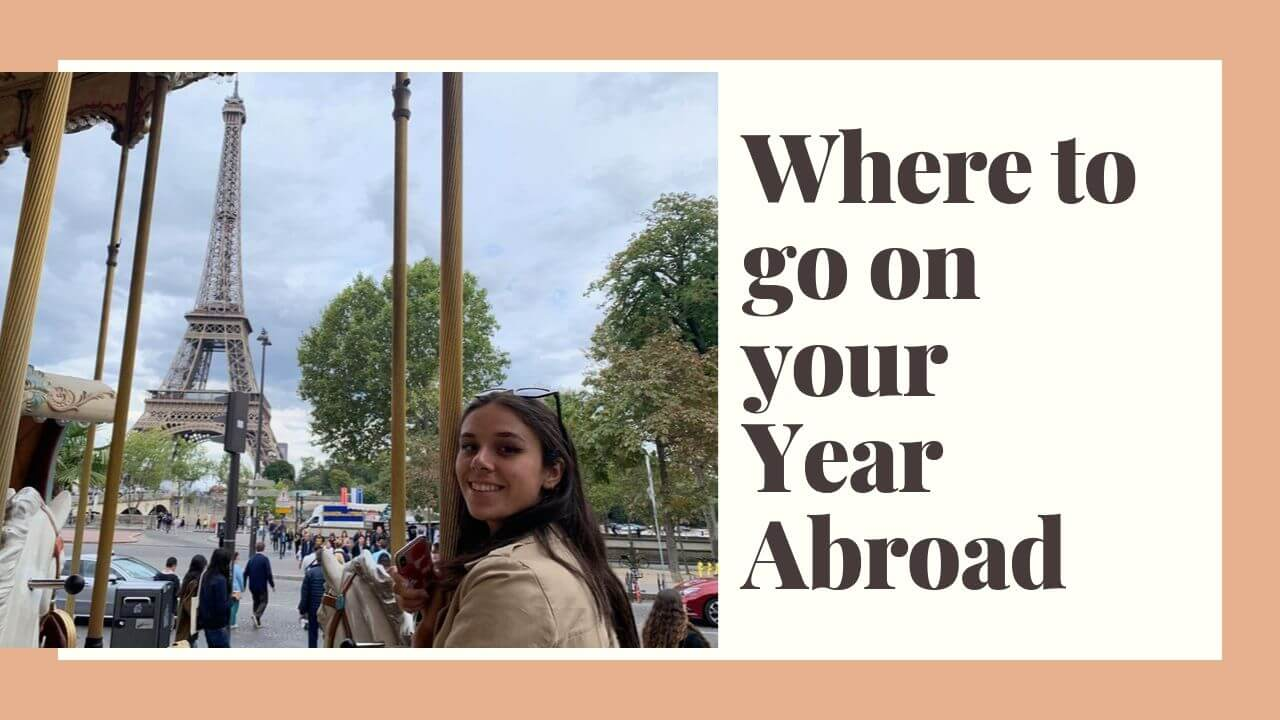Considering the Eiffel Tower is a symbol of Paris, what other Parisian spots might be featured in this graphic series? Other Parisian spots that could be featured in this graphic series might include: the Louvre Museum with its famous glass pyramid entrance, the charming neighborhoods of Montmartre with the Basilica of Sacré-Cœur, Notre-Dame Cathedral, the chic cafes and boutiques of Le Marais, the picturesque Seine River with its historic bridges, and the opulent Palace of Versailles. Each location would offer a unique glimpse into Paris’s rich history, culture, and art. 